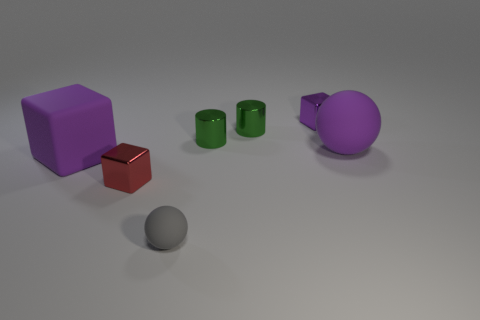Are there any other things that are the same size as the gray thing?
Keep it short and to the point. Yes. There is a large matte object on the left side of the tiny red cube; does it have the same color as the big rubber thing that is right of the tiny red shiny block?
Make the answer very short. Yes. How many cylinders are either purple metallic objects or small rubber things?
Provide a succinct answer. 0. Is the number of big cubes to the right of the big purple matte block the same as the number of cyan metallic cylinders?
Offer a terse response. Yes. What is the purple object in front of the matte sphere that is behind the metallic block on the left side of the small gray sphere made of?
Offer a terse response. Rubber. What is the material of the other block that is the same color as the big matte block?
Your answer should be compact. Metal. How many objects are either spheres in front of the big purple block or large yellow metallic cubes?
Give a very brief answer. 1. What number of objects are either big purple rubber cubes or things that are behind the big purple rubber ball?
Make the answer very short. 4. How many matte objects are left of the big matte thing on the left side of the ball behind the tiny ball?
Provide a short and direct response. 0. There is a purple object that is the same size as the purple ball; what is its material?
Your answer should be very brief. Rubber. 